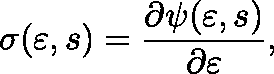<formula> <loc_0><loc_0><loc_500><loc_500>\sigma ( \varepsilon , s ) = \frac { \partial \psi ( \varepsilon , s ) } { \partial \varepsilon } ,</formula> 